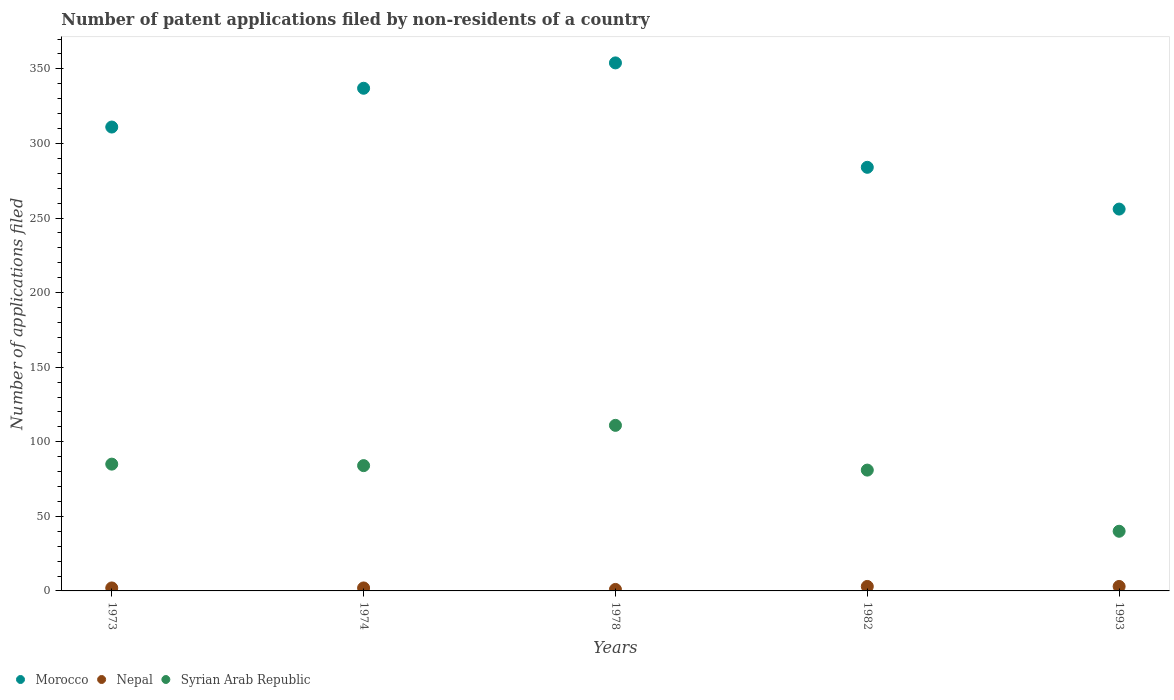How many different coloured dotlines are there?
Provide a succinct answer. 3. Is the number of dotlines equal to the number of legend labels?
Offer a terse response. Yes. What is the number of applications filed in Morocco in 1982?
Make the answer very short. 284. Across all years, what is the maximum number of applications filed in Syrian Arab Republic?
Give a very brief answer. 111. In which year was the number of applications filed in Nepal minimum?
Your answer should be very brief. 1978. What is the total number of applications filed in Syrian Arab Republic in the graph?
Offer a very short reply. 401. What is the difference between the number of applications filed in Syrian Arab Republic in 1978 and the number of applications filed in Nepal in 1982?
Your answer should be compact. 108. What is the average number of applications filed in Nepal per year?
Give a very brief answer. 2.2. In the year 1973, what is the difference between the number of applications filed in Nepal and number of applications filed in Syrian Arab Republic?
Provide a short and direct response. -83. In how many years, is the number of applications filed in Nepal greater than 240?
Offer a very short reply. 0. What is the ratio of the number of applications filed in Syrian Arab Republic in 1973 to that in 1974?
Provide a succinct answer. 1.01. Is the number of applications filed in Nepal in 1973 less than that in 1974?
Offer a very short reply. No. What is the difference between the highest and the second highest number of applications filed in Nepal?
Provide a short and direct response. 0. Is the number of applications filed in Syrian Arab Republic strictly greater than the number of applications filed in Morocco over the years?
Provide a succinct answer. No. How many dotlines are there?
Offer a very short reply. 3. Are the values on the major ticks of Y-axis written in scientific E-notation?
Offer a very short reply. No. Where does the legend appear in the graph?
Ensure brevity in your answer.  Bottom left. How are the legend labels stacked?
Offer a terse response. Horizontal. What is the title of the graph?
Ensure brevity in your answer.  Number of patent applications filed by non-residents of a country. What is the label or title of the X-axis?
Provide a succinct answer. Years. What is the label or title of the Y-axis?
Ensure brevity in your answer.  Number of applications filed. What is the Number of applications filed in Morocco in 1973?
Ensure brevity in your answer.  311. What is the Number of applications filed of Syrian Arab Republic in 1973?
Ensure brevity in your answer.  85. What is the Number of applications filed in Morocco in 1974?
Your answer should be very brief. 337. What is the Number of applications filed of Morocco in 1978?
Provide a short and direct response. 354. What is the Number of applications filed in Nepal in 1978?
Your answer should be very brief. 1. What is the Number of applications filed of Syrian Arab Republic in 1978?
Provide a short and direct response. 111. What is the Number of applications filed in Morocco in 1982?
Provide a short and direct response. 284. What is the Number of applications filed in Nepal in 1982?
Your answer should be compact. 3. What is the Number of applications filed of Morocco in 1993?
Your response must be concise. 256. What is the Number of applications filed in Nepal in 1993?
Make the answer very short. 3. What is the Number of applications filed of Syrian Arab Republic in 1993?
Your answer should be very brief. 40. Across all years, what is the maximum Number of applications filed of Morocco?
Keep it short and to the point. 354. Across all years, what is the maximum Number of applications filed in Nepal?
Offer a very short reply. 3. Across all years, what is the maximum Number of applications filed of Syrian Arab Republic?
Offer a terse response. 111. Across all years, what is the minimum Number of applications filed of Morocco?
Your answer should be compact. 256. Across all years, what is the minimum Number of applications filed in Nepal?
Your response must be concise. 1. What is the total Number of applications filed in Morocco in the graph?
Keep it short and to the point. 1542. What is the total Number of applications filed in Syrian Arab Republic in the graph?
Your answer should be compact. 401. What is the difference between the Number of applications filed of Morocco in 1973 and that in 1974?
Keep it short and to the point. -26. What is the difference between the Number of applications filed in Nepal in 1973 and that in 1974?
Your answer should be very brief. 0. What is the difference between the Number of applications filed of Morocco in 1973 and that in 1978?
Your answer should be compact. -43. What is the difference between the Number of applications filed in Nepal in 1973 and that in 1982?
Ensure brevity in your answer.  -1. What is the difference between the Number of applications filed in Syrian Arab Republic in 1973 and that in 1982?
Offer a terse response. 4. What is the difference between the Number of applications filed of Morocco in 1973 and that in 1993?
Keep it short and to the point. 55. What is the difference between the Number of applications filed of Syrian Arab Republic in 1973 and that in 1993?
Provide a short and direct response. 45. What is the difference between the Number of applications filed in Morocco in 1974 and that in 1978?
Your answer should be compact. -17. What is the difference between the Number of applications filed in Nepal in 1974 and that in 1978?
Keep it short and to the point. 1. What is the difference between the Number of applications filed in Syrian Arab Republic in 1974 and that in 1978?
Offer a very short reply. -27. What is the difference between the Number of applications filed of Nepal in 1974 and that in 1982?
Your answer should be compact. -1. What is the difference between the Number of applications filed of Nepal in 1974 and that in 1993?
Your response must be concise. -1. What is the difference between the Number of applications filed in Syrian Arab Republic in 1974 and that in 1993?
Offer a very short reply. 44. What is the difference between the Number of applications filed of Syrian Arab Republic in 1978 and that in 1982?
Provide a succinct answer. 30. What is the difference between the Number of applications filed in Morocco in 1978 and that in 1993?
Provide a succinct answer. 98. What is the difference between the Number of applications filed of Syrian Arab Republic in 1978 and that in 1993?
Your answer should be very brief. 71. What is the difference between the Number of applications filed in Morocco in 1982 and that in 1993?
Provide a succinct answer. 28. What is the difference between the Number of applications filed of Nepal in 1982 and that in 1993?
Offer a terse response. 0. What is the difference between the Number of applications filed of Syrian Arab Republic in 1982 and that in 1993?
Make the answer very short. 41. What is the difference between the Number of applications filed of Morocco in 1973 and the Number of applications filed of Nepal in 1974?
Ensure brevity in your answer.  309. What is the difference between the Number of applications filed of Morocco in 1973 and the Number of applications filed of Syrian Arab Republic in 1974?
Offer a terse response. 227. What is the difference between the Number of applications filed in Nepal in 1973 and the Number of applications filed in Syrian Arab Republic in 1974?
Your answer should be compact. -82. What is the difference between the Number of applications filed in Morocco in 1973 and the Number of applications filed in Nepal in 1978?
Provide a succinct answer. 310. What is the difference between the Number of applications filed in Morocco in 1973 and the Number of applications filed in Syrian Arab Republic in 1978?
Make the answer very short. 200. What is the difference between the Number of applications filed of Nepal in 1973 and the Number of applications filed of Syrian Arab Republic in 1978?
Keep it short and to the point. -109. What is the difference between the Number of applications filed of Morocco in 1973 and the Number of applications filed of Nepal in 1982?
Keep it short and to the point. 308. What is the difference between the Number of applications filed of Morocco in 1973 and the Number of applications filed of Syrian Arab Republic in 1982?
Your answer should be very brief. 230. What is the difference between the Number of applications filed of Nepal in 1973 and the Number of applications filed of Syrian Arab Republic in 1982?
Ensure brevity in your answer.  -79. What is the difference between the Number of applications filed of Morocco in 1973 and the Number of applications filed of Nepal in 1993?
Offer a very short reply. 308. What is the difference between the Number of applications filed in Morocco in 1973 and the Number of applications filed in Syrian Arab Republic in 1993?
Your response must be concise. 271. What is the difference between the Number of applications filed of Nepal in 1973 and the Number of applications filed of Syrian Arab Republic in 1993?
Ensure brevity in your answer.  -38. What is the difference between the Number of applications filed of Morocco in 1974 and the Number of applications filed of Nepal in 1978?
Make the answer very short. 336. What is the difference between the Number of applications filed in Morocco in 1974 and the Number of applications filed in Syrian Arab Republic in 1978?
Offer a very short reply. 226. What is the difference between the Number of applications filed of Nepal in 1974 and the Number of applications filed of Syrian Arab Republic in 1978?
Provide a short and direct response. -109. What is the difference between the Number of applications filed in Morocco in 1974 and the Number of applications filed in Nepal in 1982?
Your response must be concise. 334. What is the difference between the Number of applications filed of Morocco in 1974 and the Number of applications filed of Syrian Arab Republic in 1982?
Ensure brevity in your answer.  256. What is the difference between the Number of applications filed of Nepal in 1974 and the Number of applications filed of Syrian Arab Republic in 1982?
Make the answer very short. -79. What is the difference between the Number of applications filed of Morocco in 1974 and the Number of applications filed of Nepal in 1993?
Offer a very short reply. 334. What is the difference between the Number of applications filed in Morocco in 1974 and the Number of applications filed in Syrian Arab Republic in 1993?
Provide a short and direct response. 297. What is the difference between the Number of applications filed in Nepal in 1974 and the Number of applications filed in Syrian Arab Republic in 1993?
Provide a succinct answer. -38. What is the difference between the Number of applications filed in Morocco in 1978 and the Number of applications filed in Nepal in 1982?
Provide a succinct answer. 351. What is the difference between the Number of applications filed of Morocco in 1978 and the Number of applications filed of Syrian Arab Republic in 1982?
Keep it short and to the point. 273. What is the difference between the Number of applications filed of Nepal in 1978 and the Number of applications filed of Syrian Arab Republic in 1982?
Offer a very short reply. -80. What is the difference between the Number of applications filed of Morocco in 1978 and the Number of applications filed of Nepal in 1993?
Your answer should be compact. 351. What is the difference between the Number of applications filed in Morocco in 1978 and the Number of applications filed in Syrian Arab Republic in 1993?
Give a very brief answer. 314. What is the difference between the Number of applications filed of Nepal in 1978 and the Number of applications filed of Syrian Arab Republic in 1993?
Provide a succinct answer. -39. What is the difference between the Number of applications filed of Morocco in 1982 and the Number of applications filed of Nepal in 1993?
Offer a very short reply. 281. What is the difference between the Number of applications filed in Morocco in 1982 and the Number of applications filed in Syrian Arab Republic in 1993?
Provide a short and direct response. 244. What is the difference between the Number of applications filed in Nepal in 1982 and the Number of applications filed in Syrian Arab Republic in 1993?
Your answer should be very brief. -37. What is the average Number of applications filed in Morocco per year?
Offer a very short reply. 308.4. What is the average Number of applications filed in Nepal per year?
Offer a terse response. 2.2. What is the average Number of applications filed of Syrian Arab Republic per year?
Give a very brief answer. 80.2. In the year 1973, what is the difference between the Number of applications filed in Morocco and Number of applications filed in Nepal?
Offer a very short reply. 309. In the year 1973, what is the difference between the Number of applications filed in Morocco and Number of applications filed in Syrian Arab Republic?
Offer a terse response. 226. In the year 1973, what is the difference between the Number of applications filed of Nepal and Number of applications filed of Syrian Arab Republic?
Your response must be concise. -83. In the year 1974, what is the difference between the Number of applications filed of Morocco and Number of applications filed of Nepal?
Keep it short and to the point. 335. In the year 1974, what is the difference between the Number of applications filed in Morocco and Number of applications filed in Syrian Arab Republic?
Your answer should be very brief. 253. In the year 1974, what is the difference between the Number of applications filed of Nepal and Number of applications filed of Syrian Arab Republic?
Your answer should be compact. -82. In the year 1978, what is the difference between the Number of applications filed of Morocco and Number of applications filed of Nepal?
Your response must be concise. 353. In the year 1978, what is the difference between the Number of applications filed of Morocco and Number of applications filed of Syrian Arab Republic?
Provide a succinct answer. 243. In the year 1978, what is the difference between the Number of applications filed of Nepal and Number of applications filed of Syrian Arab Republic?
Your answer should be very brief. -110. In the year 1982, what is the difference between the Number of applications filed in Morocco and Number of applications filed in Nepal?
Offer a terse response. 281. In the year 1982, what is the difference between the Number of applications filed in Morocco and Number of applications filed in Syrian Arab Republic?
Give a very brief answer. 203. In the year 1982, what is the difference between the Number of applications filed of Nepal and Number of applications filed of Syrian Arab Republic?
Provide a short and direct response. -78. In the year 1993, what is the difference between the Number of applications filed in Morocco and Number of applications filed in Nepal?
Offer a very short reply. 253. In the year 1993, what is the difference between the Number of applications filed of Morocco and Number of applications filed of Syrian Arab Republic?
Your response must be concise. 216. In the year 1993, what is the difference between the Number of applications filed in Nepal and Number of applications filed in Syrian Arab Republic?
Your answer should be very brief. -37. What is the ratio of the Number of applications filed in Morocco in 1973 to that in 1974?
Keep it short and to the point. 0.92. What is the ratio of the Number of applications filed of Nepal in 1973 to that in 1974?
Offer a terse response. 1. What is the ratio of the Number of applications filed of Syrian Arab Republic in 1973 to that in 1974?
Your answer should be compact. 1.01. What is the ratio of the Number of applications filed of Morocco in 1973 to that in 1978?
Offer a very short reply. 0.88. What is the ratio of the Number of applications filed of Syrian Arab Republic in 1973 to that in 1978?
Make the answer very short. 0.77. What is the ratio of the Number of applications filed in Morocco in 1973 to that in 1982?
Give a very brief answer. 1.1. What is the ratio of the Number of applications filed of Nepal in 1973 to that in 1982?
Offer a terse response. 0.67. What is the ratio of the Number of applications filed in Syrian Arab Republic in 1973 to that in 1982?
Give a very brief answer. 1.05. What is the ratio of the Number of applications filed in Morocco in 1973 to that in 1993?
Your answer should be compact. 1.21. What is the ratio of the Number of applications filed of Syrian Arab Republic in 1973 to that in 1993?
Provide a succinct answer. 2.12. What is the ratio of the Number of applications filed of Morocco in 1974 to that in 1978?
Keep it short and to the point. 0.95. What is the ratio of the Number of applications filed of Syrian Arab Republic in 1974 to that in 1978?
Offer a very short reply. 0.76. What is the ratio of the Number of applications filed in Morocco in 1974 to that in 1982?
Offer a terse response. 1.19. What is the ratio of the Number of applications filed of Nepal in 1974 to that in 1982?
Your response must be concise. 0.67. What is the ratio of the Number of applications filed in Morocco in 1974 to that in 1993?
Provide a short and direct response. 1.32. What is the ratio of the Number of applications filed in Morocco in 1978 to that in 1982?
Ensure brevity in your answer.  1.25. What is the ratio of the Number of applications filed of Nepal in 1978 to that in 1982?
Your answer should be very brief. 0.33. What is the ratio of the Number of applications filed in Syrian Arab Republic in 1978 to that in 1982?
Provide a short and direct response. 1.37. What is the ratio of the Number of applications filed in Morocco in 1978 to that in 1993?
Keep it short and to the point. 1.38. What is the ratio of the Number of applications filed of Nepal in 1978 to that in 1993?
Ensure brevity in your answer.  0.33. What is the ratio of the Number of applications filed of Syrian Arab Republic in 1978 to that in 1993?
Your answer should be compact. 2.77. What is the ratio of the Number of applications filed in Morocco in 1982 to that in 1993?
Make the answer very short. 1.11. What is the ratio of the Number of applications filed of Nepal in 1982 to that in 1993?
Provide a short and direct response. 1. What is the ratio of the Number of applications filed of Syrian Arab Republic in 1982 to that in 1993?
Your answer should be very brief. 2.02. What is the difference between the highest and the second highest Number of applications filed of Morocco?
Your response must be concise. 17. What is the difference between the highest and the lowest Number of applications filed in Syrian Arab Republic?
Keep it short and to the point. 71. 